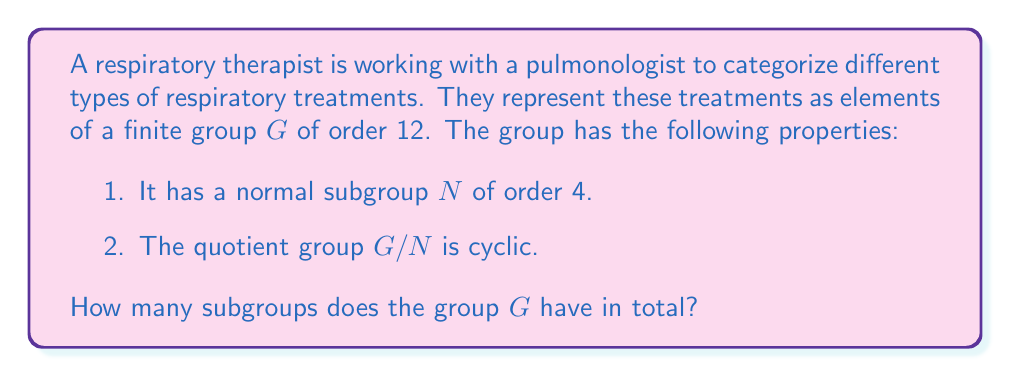Solve this math problem. Let's approach this step-by-step:

1) First, we need to identify the structure of the group $G$. Given the information, we can deduce that $G$ is isomorphic to $C_3 \rtimes C_4$ (semi-direct product of $C_3$ and $C_4$).

2) To find the number of subgroups, we'll count subgroups of each possible order:

   a) Order 1: Always just the trivial subgroup {e}.
   
   b) Order 2: There must be 1 subgroup of order 2 (from the normal subgroup $N$).
   
   c) Order 3: There is 1 subgroup of order 3 (from the quotient group $G/N$).
   
   d) Order 4: The normal subgroup $N$ is of order 4. It could be either $C_4$ or $C_2 \times C_2$. Given that $G/N$ is cyclic, $N$ must be $C_4$. So there is 1 subgroup of order 4.
   
   e) Order 6: There is 1 subgroup of order 6 (combining the subgroups of order 2 and 3).
   
   f) Order 12: The whole group $G$ itself.

3) To get the total, we sum up all these subgroups:

   $$1 + 1 + 1 + 1 + 1 + 1 = 6$$

Therefore, the group $G$ has 6 subgroups in total.
Answer: 6 subgroups 